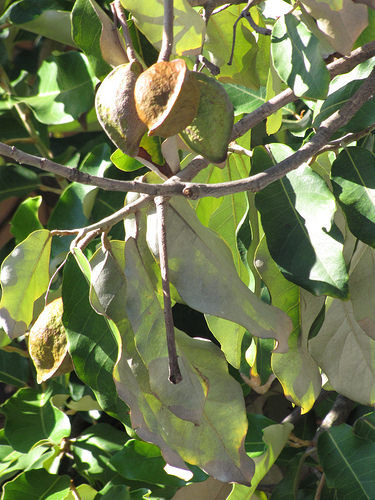<image>
Is the fruits on the tree? Yes. Looking at the image, I can see the fruits is positioned on top of the tree, with the tree providing support. Is the leaf behind the leaf? Yes. From this viewpoint, the leaf is positioned behind the leaf, with the leaf partially or fully occluding the leaf. 